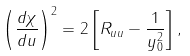<formula> <loc_0><loc_0><loc_500><loc_500>\left ( \frac { d \chi } { d u } \right ) ^ { 2 } = 2 \left [ R _ { u u } - \frac { 1 } { y _ { 0 } ^ { 2 } } \right ] ,</formula> 